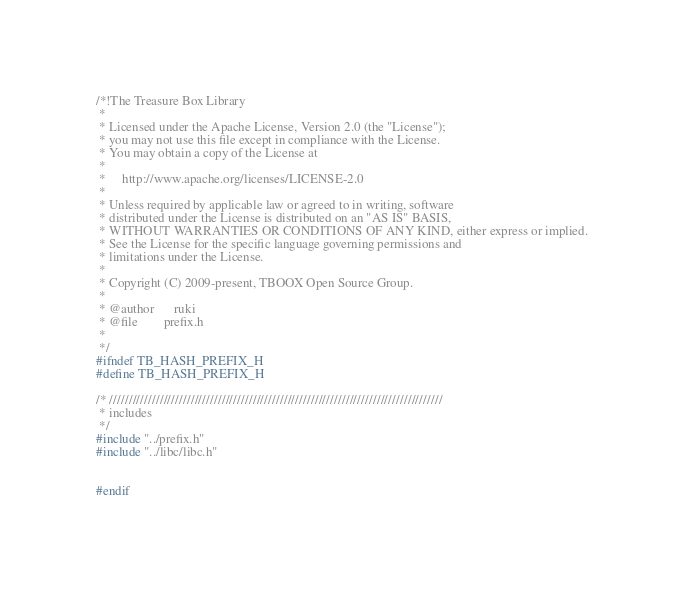<code> <loc_0><loc_0><loc_500><loc_500><_C_>/*!The Treasure Box Library
 *
 * Licensed under the Apache License, Version 2.0 (the "License");
 * you may not use this file except in compliance with the License.
 * You may obtain a copy of the License at
 *
 *     http://www.apache.org/licenses/LICENSE-2.0
 *
 * Unless required by applicable law or agreed to in writing, software
 * distributed under the License is distributed on an "AS IS" BASIS,
 * WITHOUT WARRANTIES OR CONDITIONS OF ANY KIND, either express or implied.
 * See the License for the specific language governing permissions and
 * limitations under the License.
 *
 * Copyright (C) 2009-present, TBOOX Open Source Group.
 *
 * @author      ruki
 * @file        prefix.h
 *
 */
#ifndef TB_HASH_PREFIX_H
#define TB_HASH_PREFIX_H

/* //////////////////////////////////////////////////////////////////////////////////////
 * includes
 */
#include "../prefix.h"
#include "../libc/libc.h"


#endif
</code> 